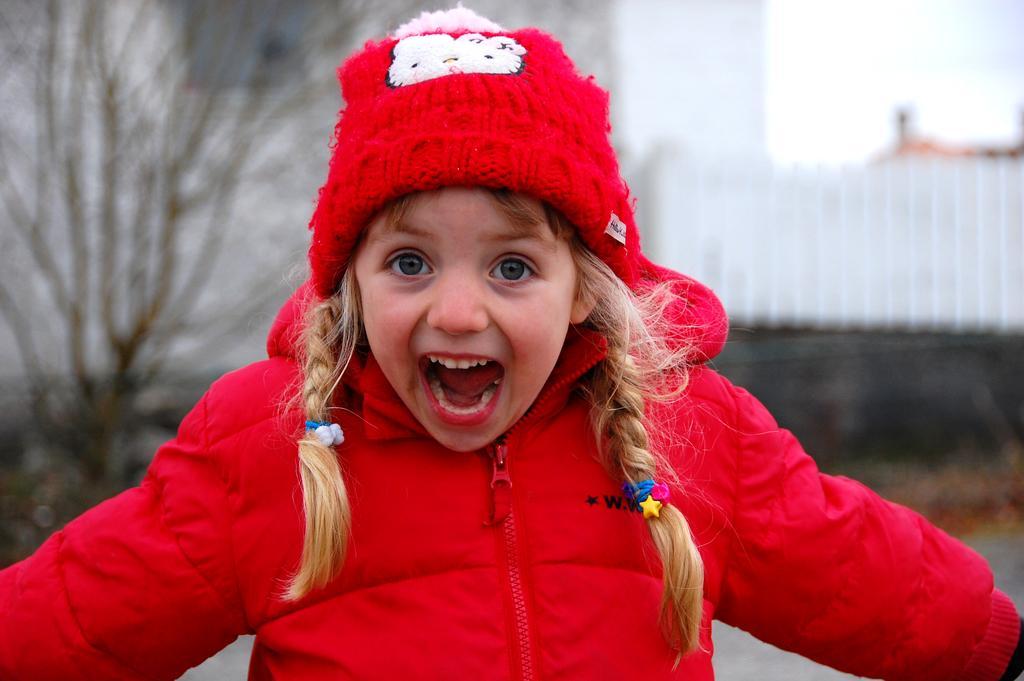Can you describe this image briefly? In this image we can see a baby girl wearing a red color jacket and she is shouting. Here we can see a tree on the left side. 